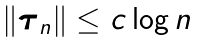<formula> <loc_0><loc_0><loc_500><loc_500>\| \boldsymbol \tau _ { n } \| \leq c \log n</formula> 